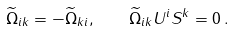<formula> <loc_0><loc_0><loc_500><loc_500>\widetilde { \Omega } _ { i k } = - \widetilde { \Omega } _ { k i } , \quad \widetilde { \Omega } _ { i k } U ^ { i } S ^ { k } = 0 \, .</formula> 